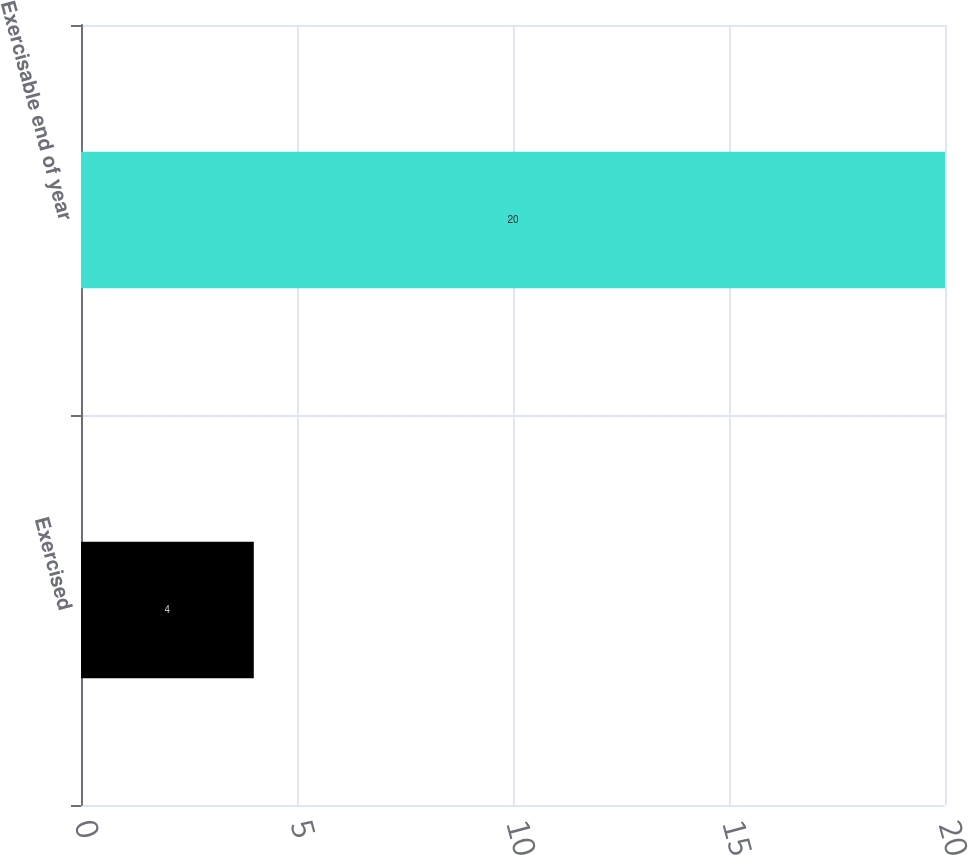Convert chart to OTSL. <chart><loc_0><loc_0><loc_500><loc_500><bar_chart><fcel>Exercised<fcel>Exercisable end of year<nl><fcel>4<fcel>20<nl></chart> 